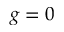Convert formula to latex. <formula><loc_0><loc_0><loc_500><loc_500>g = 0</formula> 